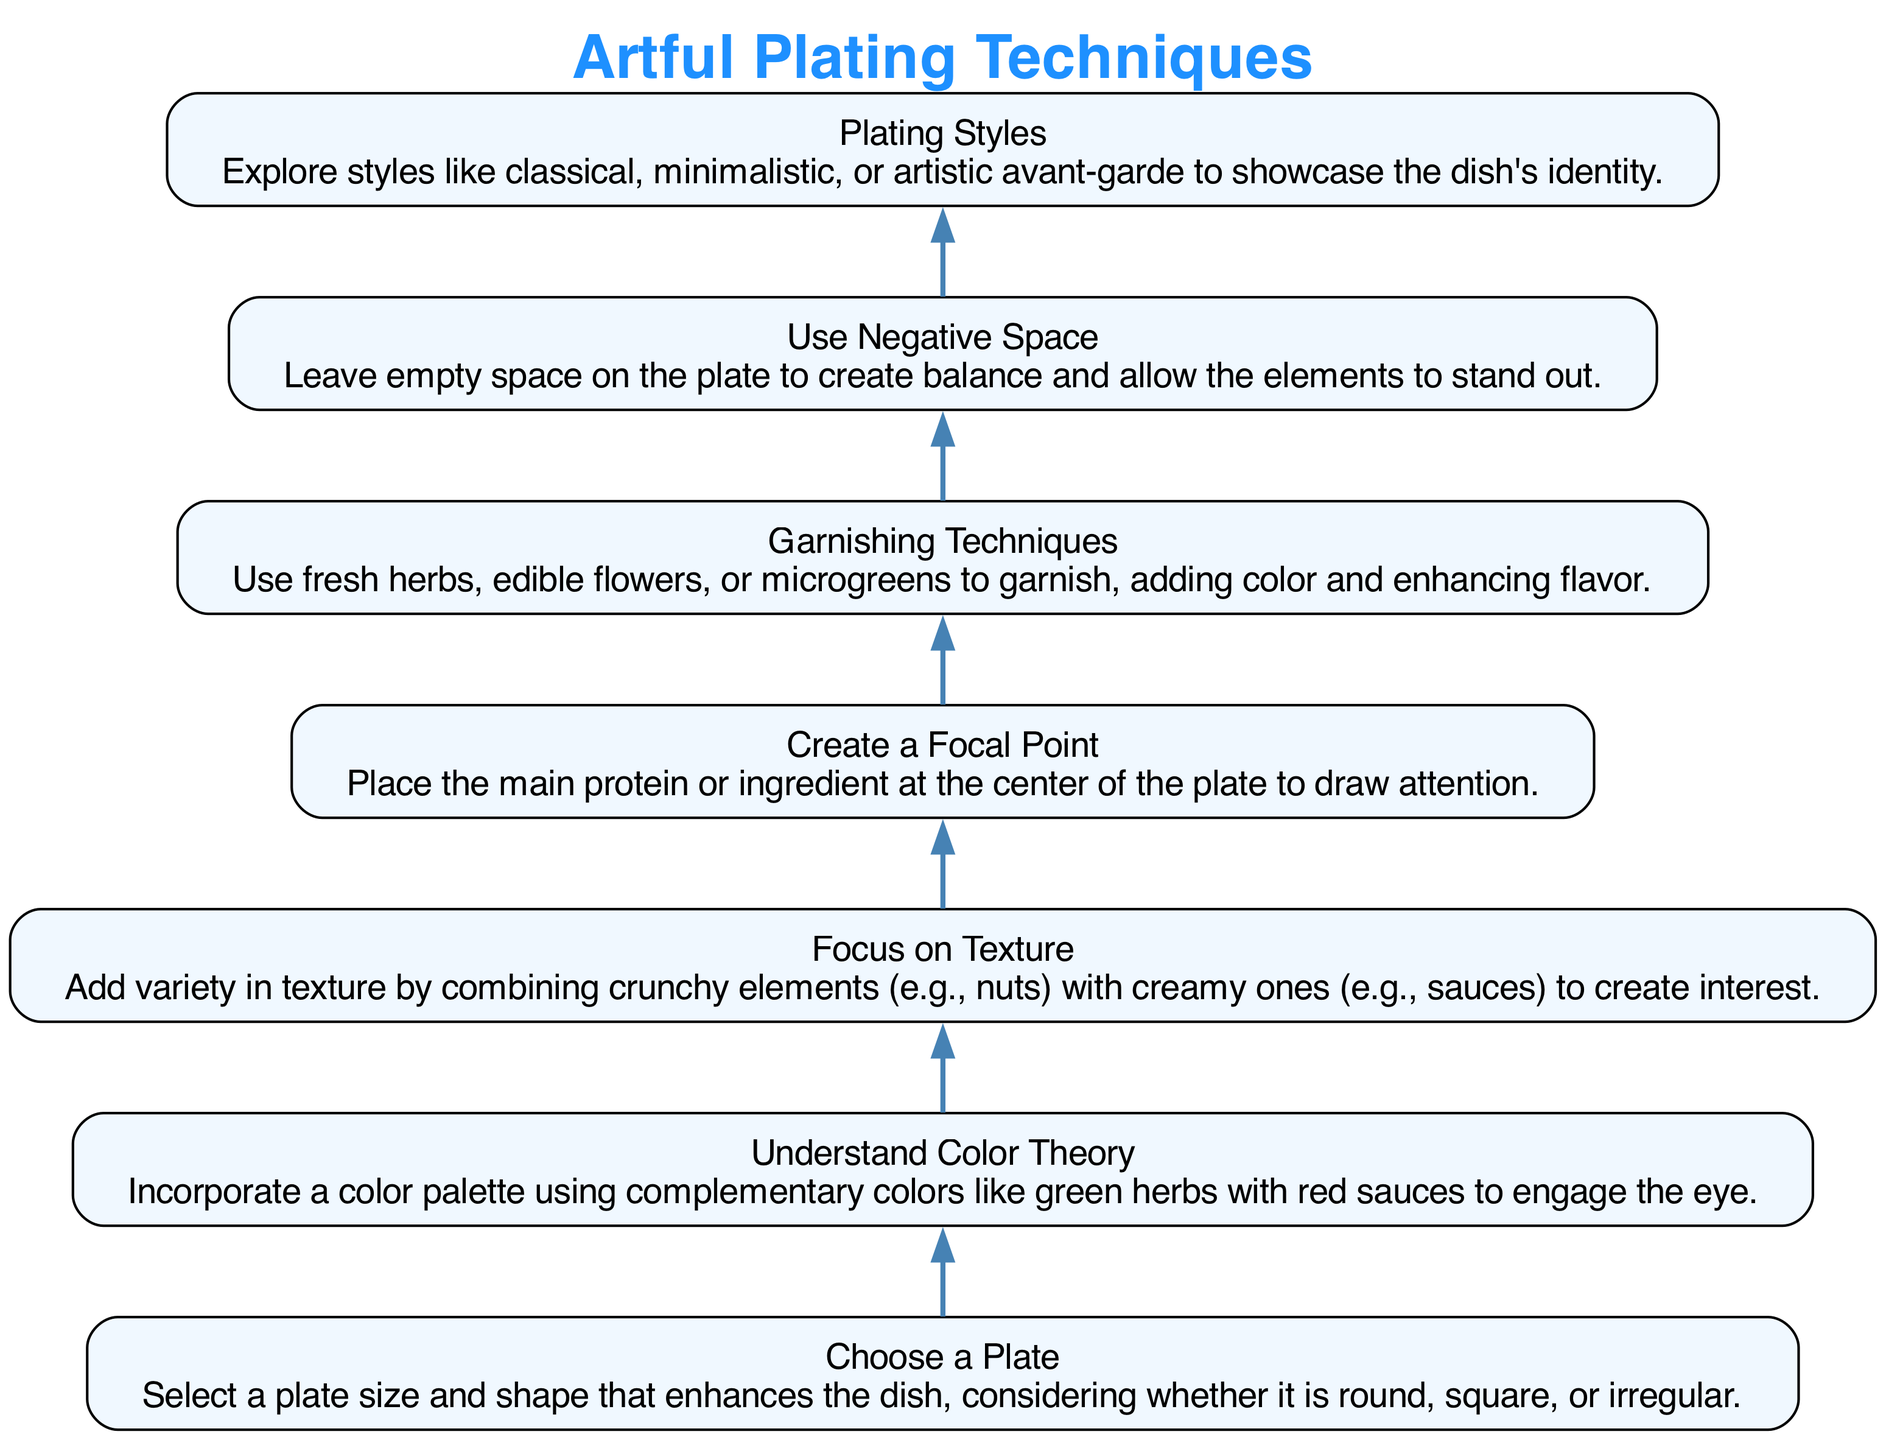What is the first step in the plating process? The diagram starts with the first element, which is "Choose a Plate". It indicates the initial action needed before any other steps can be taken in the plating process.
Answer: Choose a Plate How many garnishing techniques are mentioned? The diagram lists one specific element that addresses garnishing, named "Garnishing Techniques". Since this is a single step, the count is one.
Answer: One What element focuses on incorporating texture? The diagram indicates that "Focus on Texture" is the element that specifically addresses combining different textures in plating, such as crunchy and creamy elements.
Answer: Focus on Texture Which element symbolizes the main component of a dish? In the diagram, the element "Create a Focal Point" emphasizes the importance of placing the main protein or ingredient at the center of the plate, symbolizing the centerpiece of the dish.
Answer: Create a Focal Point How does the use of negative space contribute to plating? The element "Use Negative Space" in the diagram explains that leaving empty space on the plate creates balance, thus allowing the other elements to stand out more prominently.
Answer: Use Negative Space What plating technique is suggested for enhancing visual appeal with color? According to the diagram, "Understand Color Theory" is the key technique for enhancing visual appeal through the effective use of a complementary color palette.
Answer: Understand Color Theory What is the last step in the bottom-up flow? The last step highlighted in the diagram is "Plating Styles", indicating different styles such as classical, minimalistic, or artistic avant-garde to finish the plating process.
Answer: Plating Styles What technique adds visual interest through additional elements? The element "Garnishing Techniques" discusses using fresh herbs or edible flowers as additions that provide not only color but also enhance flavor, thus adding visual interest.
Answer: Garnishing Techniques From the first to last element, how many total steps are represented? The diagram encompasses a total of seven distinct elements representing the steps in the artful plating process, spanning from "Choose a Plate" to "Plating Styles".
Answer: Seven 